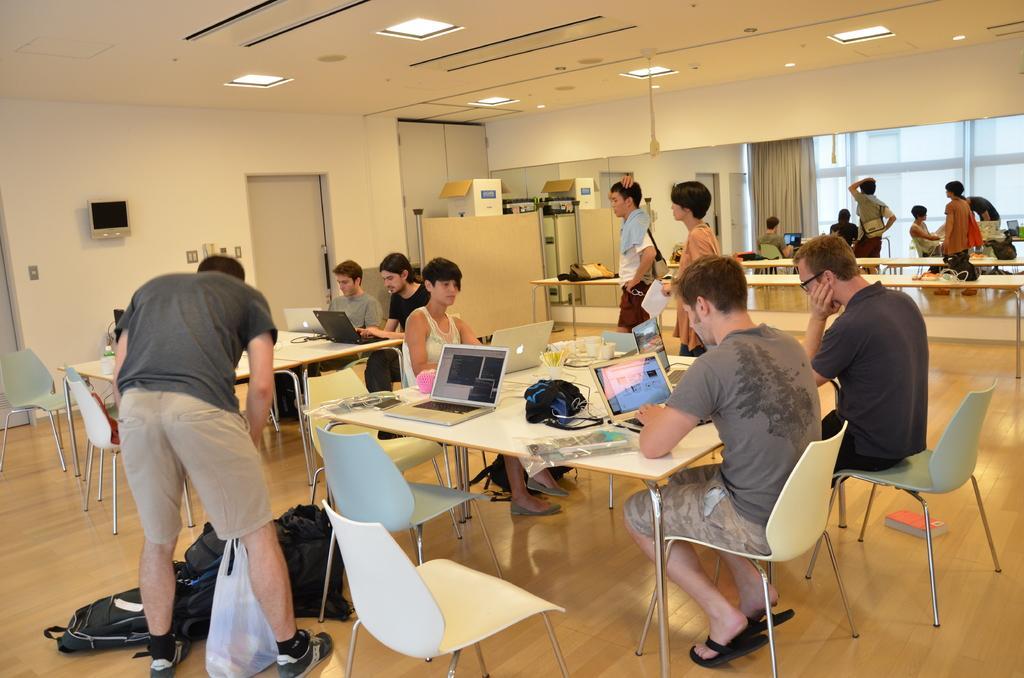Please provide a concise description of this image. In this image there are group of people, few are standing and few are sitting. At the top there are lights, at the bottom there are bags, book. There are laptops,bags, wires on the table. At the back there is a curtain and at the left there is a door. 